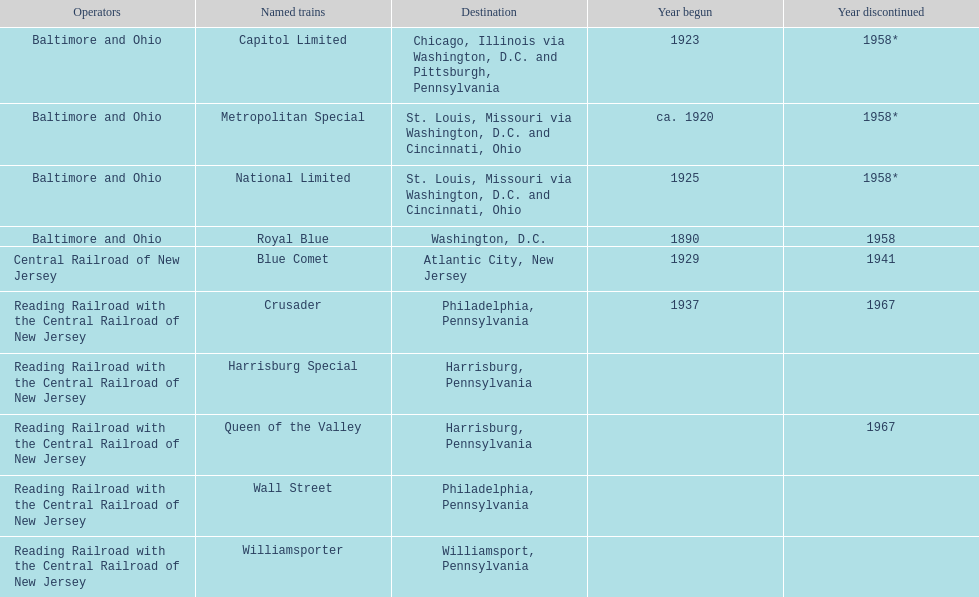What is the overall number of named trains? 10. 